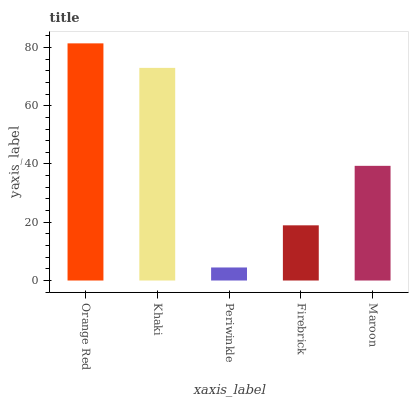Is Khaki the minimum?
Answer yes or no. No. Is Khaki the maximum?
Answer yes or no. No. Is Orange Red greater than Khaki?
Answer yes or no. Yes. Is Khaki less than Orange Red?
Answer yes or no. Yes. Is Khaki greater than Orange Red?
Answer yes or no. No. Is Orange Red less than Khaki?
Answer yes or no. No. Is Maroon the high median?
Answer yes or no. Yes. Is Maroon the low median?
Answer yes or no. Yes. Is Khaki the high median?
Answer yes or no. No. Is Khaki the low median?
Answer yes or no. No. 